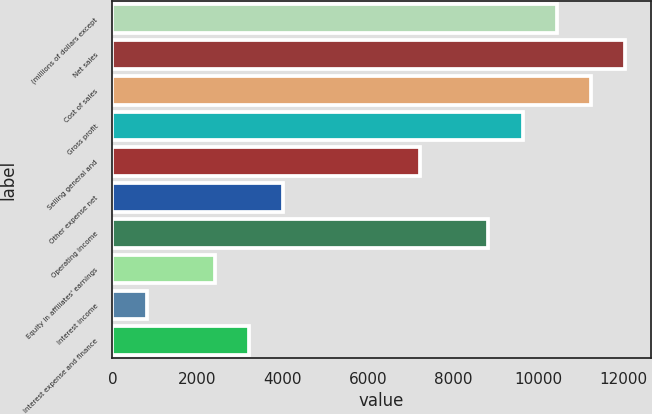Convert chart. <chart><loc_0><loc_0><loc_500><loc_500><bar_chart><fcel>(millions of dollars except<fcel>Net sales<fcel>Cost of sales<fcel>Gross profit<fcel>Selling general and<fcel>Other expense net<fcel>Operating income<fcel>Equity in affiliates' earnings<fcel>Interest income<fcel>Interest expense and finance<nl><fcel>10429.4<fcel>12033.5<fcel>11231.4<fcel>9627.3<fcel>7221.15<fcel>4012.95<fcel>8825.25<fcel>2408.85<fcel>804.75<fcel>3210.9<nl></chart> 